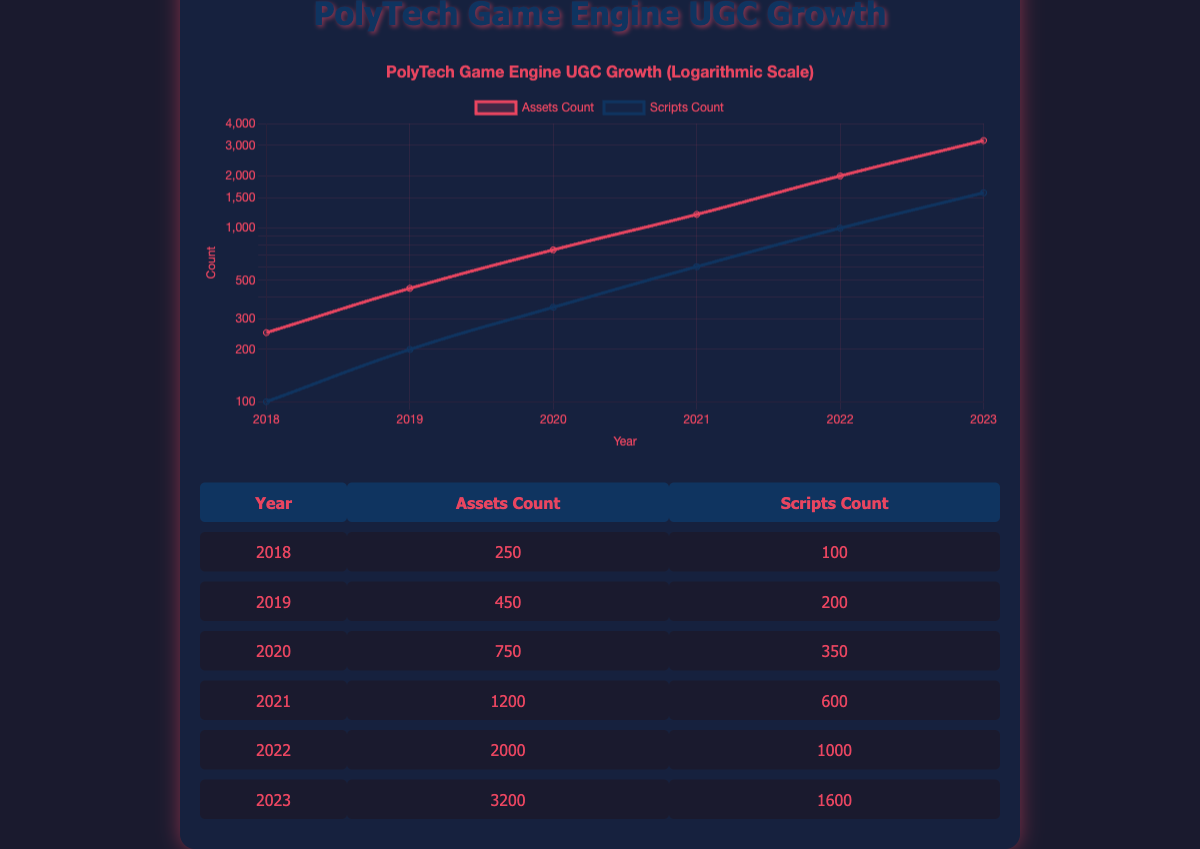What was the assets count in 2021? In the table, I can directly look for the row corresponding to the year 2021. The assets count listed there is 1200.
Answer: 1200 What is the total count of scripts from 2018 to 2023? To find the total count of scripts, I need to sum the scripts counts from each year: 100 + 200 + 350 + 600 + 1000 + 1600 = 2850.
Answer: 2850 Did the assets count increase every year from 2018 to 2023? By checking the assets counts for each year (250, 450, 750, 1200, 2000, 3200), I see that they all are increasing in order, confirming it increased every year.
Answer: Yes What is the average assets count from 2019 to 2023? The years involved are 2019, 2020, 2021, 2022, and 2023. The assets counts are 450, 750, 1200, 2000, and 3200. First, I sum these values: 450 + 750 + 1200 + 2000 + 3200 = 8100. Then, I divide by 5 (the number of years) to calculate the average: 8100 / 5 = 1620.
Answer: 1620 Which year experienced the largest growth in assets count compared to the previous year? I need to calculate the growth in assets count for each year by finding the difference between the current year's count and the previous year's count. The differences are: 2019 - 2018: 450 - 250 = 200, 2020 - 2019: 750 - 450 = 300, 2021 - 2020: 1200 - 750 = 450, 2022 - 2021: 2000 - 1200 = 800, 2023 - 2022: 3200 - 2000 = 1200. The largest growth is from 2022 to 2023, which is 1200.
Answer: 2022 to 2023 What year had both assets count and scripts count exceeding 1000? By examining the table, I see that the year 2022 has both the assets count (2000) and the scripts count (1000) exceeding 1000.
Answer: 2022 